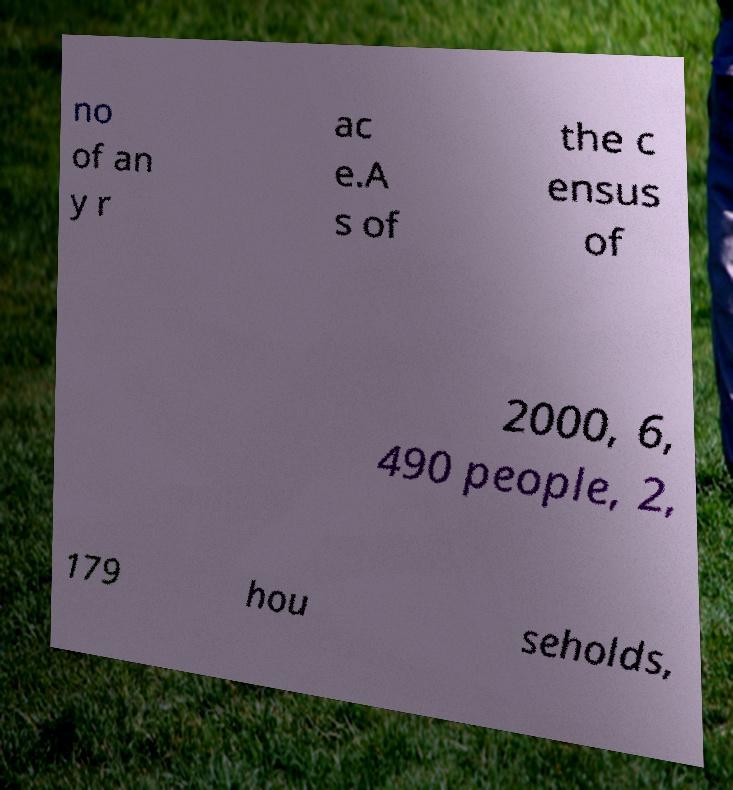For documentation purposes, I need the text within this image transcribed. Could you provide that? no of an y r ac e.A s of the c ensus of 2000, 6, 490 people, 2, 179 hou seholds, 